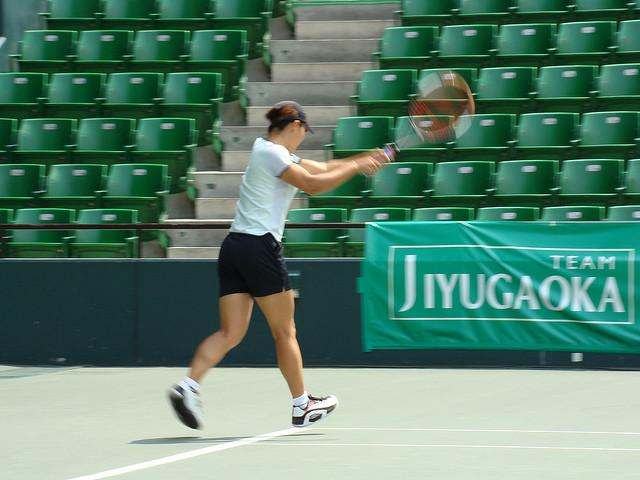What person played a similar sport to this person?

Choices:
A) alex morgan
B) bo jackson
C) jim kelly
D) martina navratilova martina navratilova 